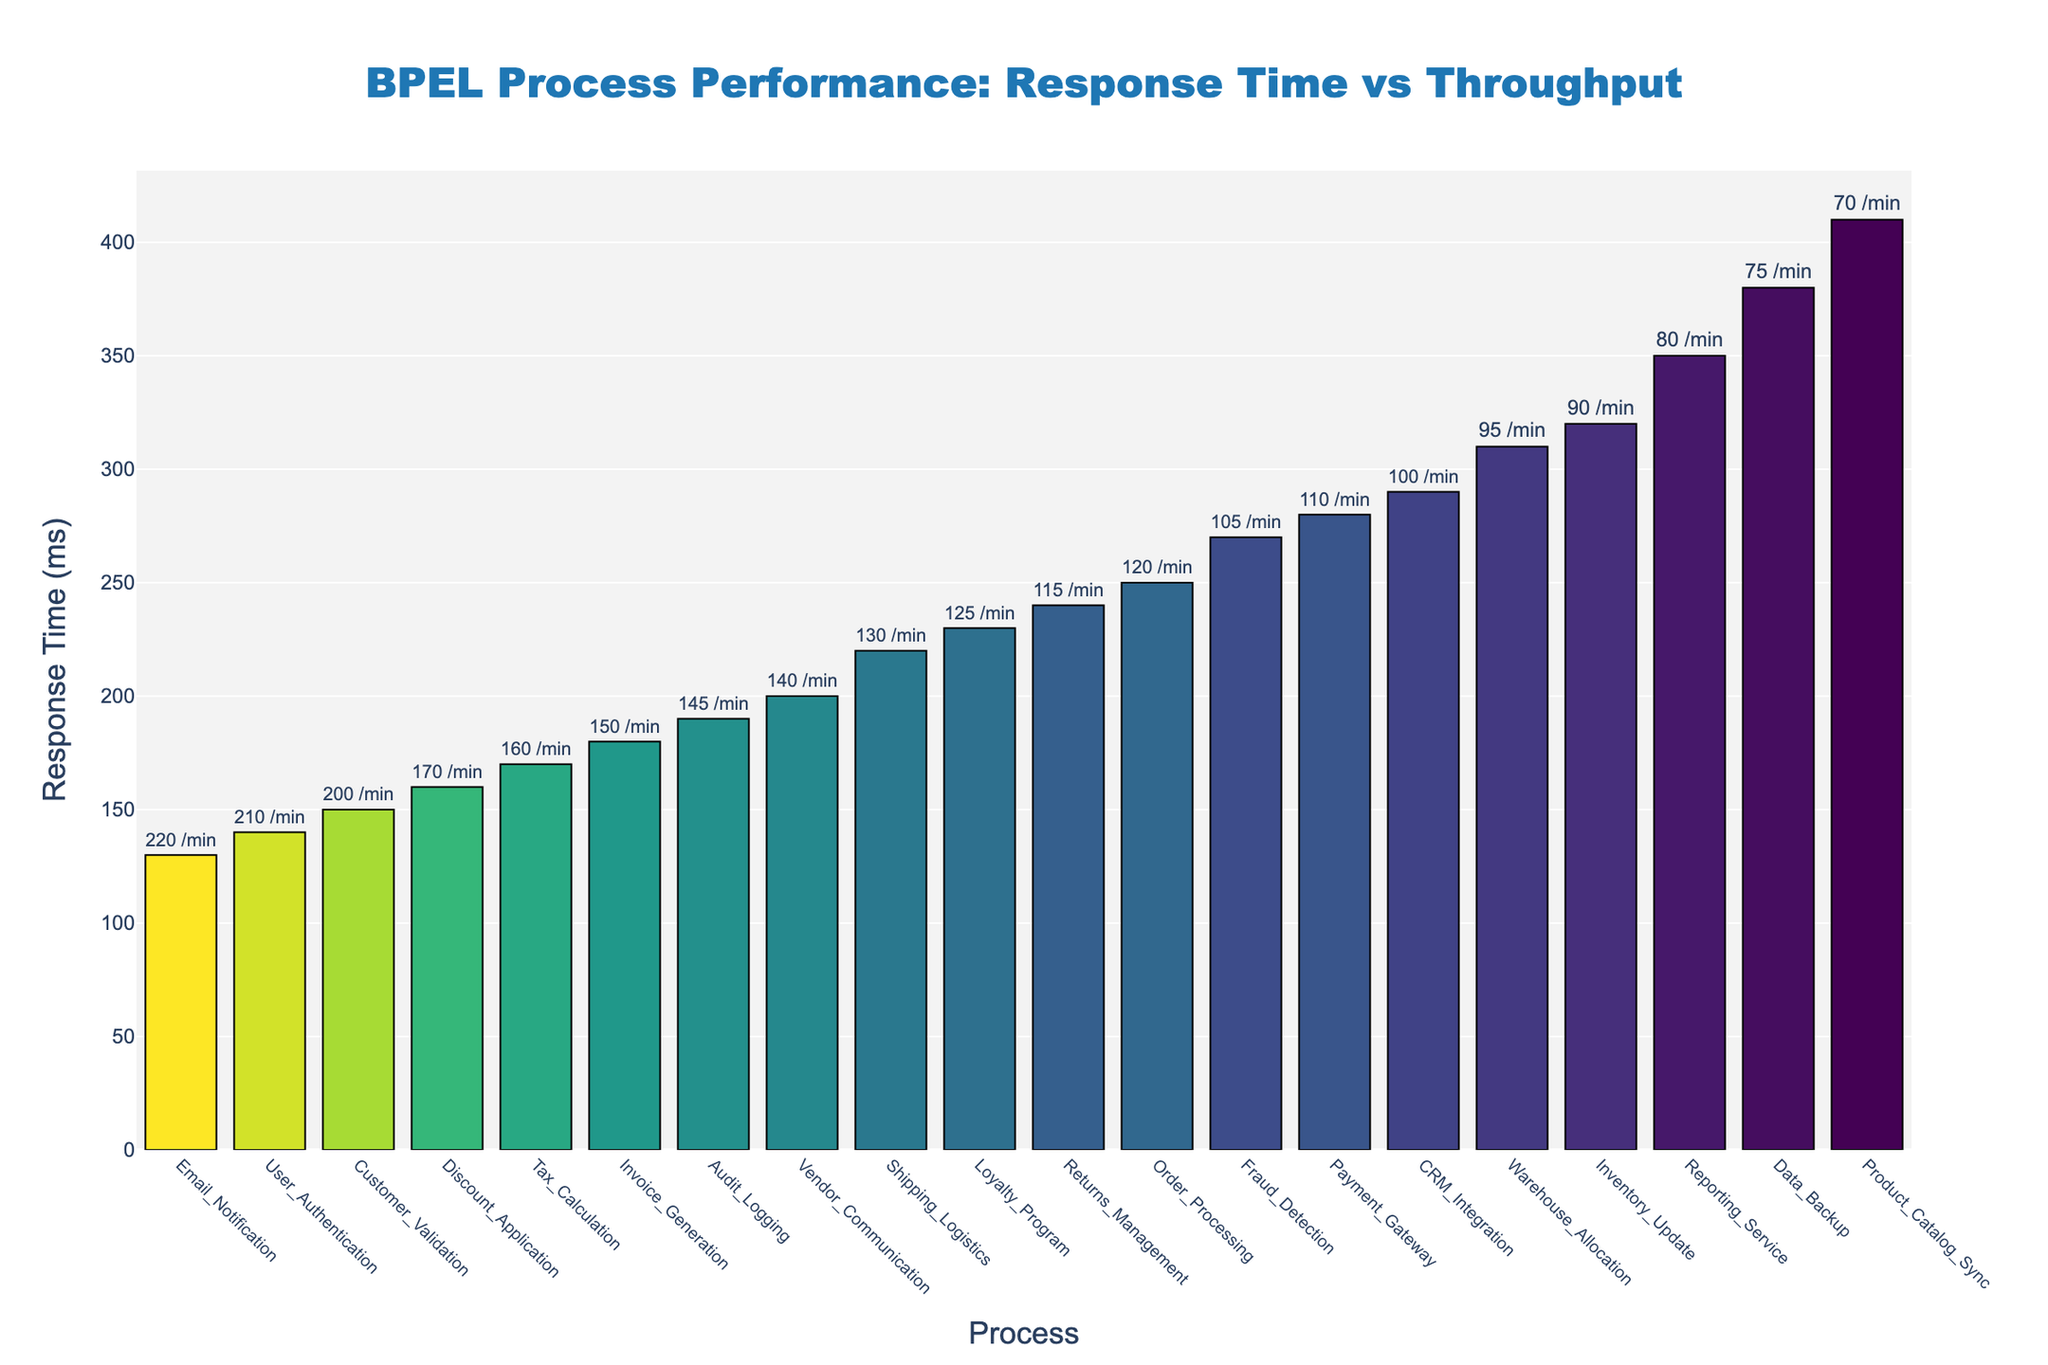What's the title of the plot? Look at the top of the figure where the title is usually placed. The title should be centered at the top of the plot.
Answer: BPEL Process Performance: Response Time vs Throughput Which process has the highest response time? Check the height of the bars representing each process and identify the tallest one, indicating the highest response time.
Answer: Product_Catalog_Sync How many processes have a response time greater than 300 ms? Count the number of bars that extend above the 300 ms mark on the y-axis.
Answer: 5 Which process has the highest throughput? Identify the process that has the highest value shown as text on top of the bars, indicating throughput per minute.
Answer: Email_Notification What is the response time difference between User_Authentication and Data_Backup? Find the response times for both User_Authentication and Data_Backup by looking at the y-axis values, then subtract the smaller value from the larger one. User_Authentication has 140 ms, and Data_Backup has 380 ms. So, 380 - 140 = 240 ms.
Answer: 240 ms Which process has the closest response time to Invoice_Generation? Locate the bar for Invoice_Generation and compare its height to the heights of the other bars to find the process that has a response time closest to it.
Answer: Tax_Calculation Is there any process with a throughput between 50/min and 60/min? Scan the values displayed on top of the bars to check if any fall between 50 and 60.
Answer: No Which process has the lowest throughput with a response time under 200 ms? First, identify processes with bars below 200 ms on the y-axis, then look at their throughput values and find the lowest one.
Answer: Customer_Validation Which process has the largest throughput difference compared to Inventory_Update? Find the throughput values for each process and calculate the absolute difference compared to Inventory_Update. Inventory_Update has 90 per minute. Compare this with other processes to find the largest difference. The largest difference is with Email_Notification at 220/min, thus the difference is 220 - 90 = 130/min.
Answer: Email_Notification What is the average response time of the processes with throughput greater than 150/min? Identify processes with throughput above 150/min, then sum their response times and divide by the number of such processes. Customer_Validation (150 ms), Email_Notification (130 ms), Tax_Calculation (170 ms), Discount_Application (160 ms), User_Authentication (140 ms). Sum = 150 + 130 + 170 + 160 + 140 = 750 ms. Average = 750 / 5 = 150 ms.
Answer: 150 ms 